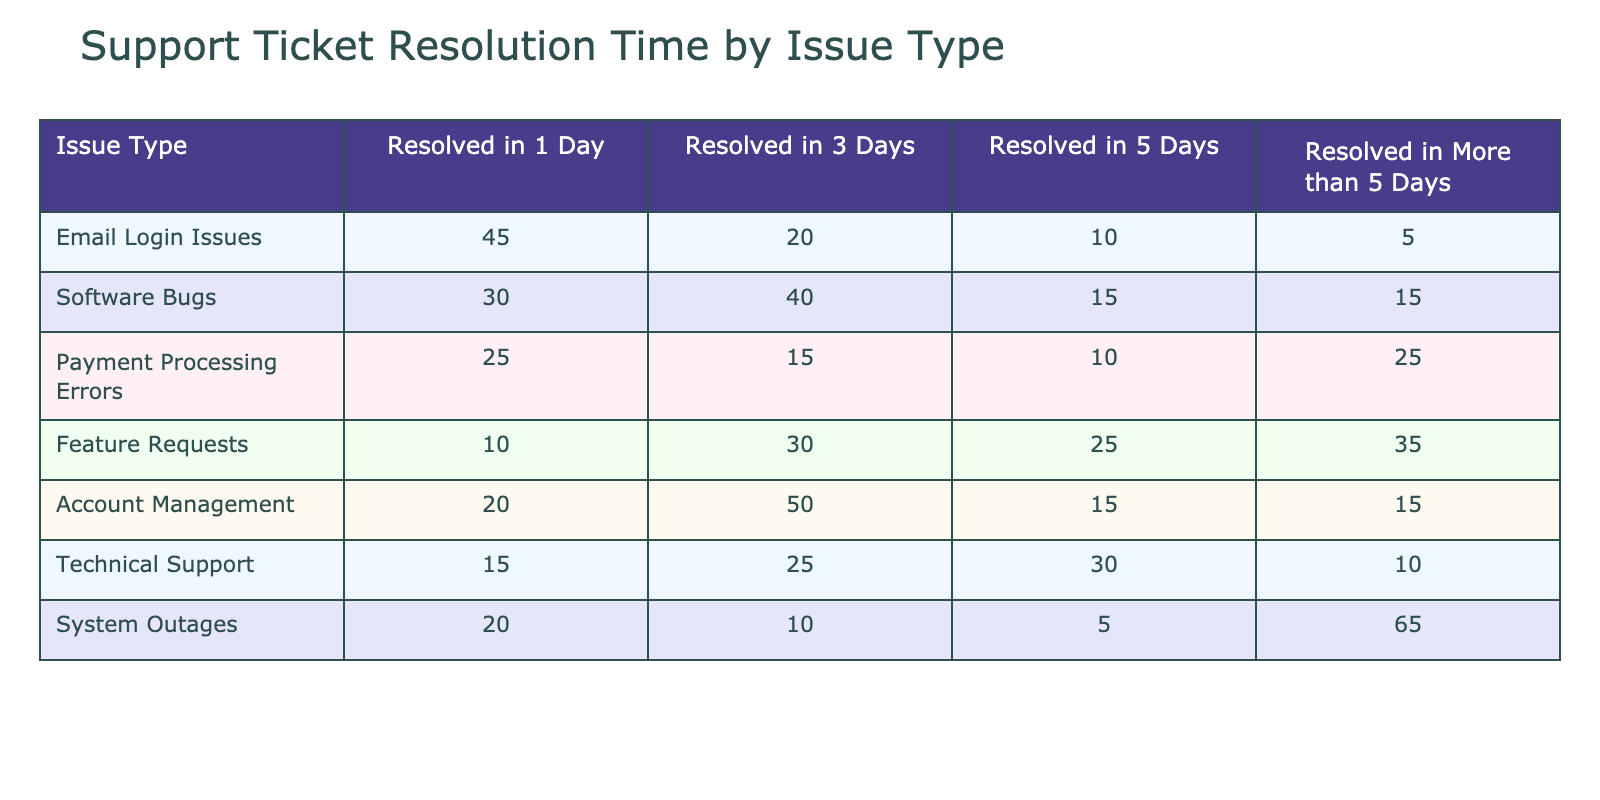What is the total number of tickets resolved in one day across all issue types? To find the total number of tickets resolved in one day, we sum the values of the "Resolved in 1 Day" column: 45 (Email Login Issues) + 30 (Software Bugs) + 25 (Payment Processing Errors) + 10 (Feature Requests) + 20 (Account Management) + 15 (Technical Support) + 20 (System Outages) = 165
Answer: 165 Which issue type took the longest to resolve on average? To determine which issue type took the longest, we need to find the row with the highest total in the "Resolved in More than 5 Days" column, as tickets going unresolved for more than 5 days indicates prolonged resolution. The highest value in this column is 65 (System Outages).
Answer: System Outages Are more tickets resolved in one day or three days across all issue types combined? We compare the totals for "Resolved in 1 Day" and "Resolved in 3 Days". The total for "Resolved in 1 Day" is 165, and for "Resolved in 3 Days" is 150. Since 165 > 150, more tickets are resolved in one day.
Answer: More tickets are resolved in one day What is the average resolution time for Feature Requests? For Feature Requests, the resolution times are weighted by the number of tickets resolved in each category: [(1*10) + (3*30) + (5*25) + (6*35)] / (10 + 30 + 25 + 35) = (10 + 90 + 125 + 210) / 100 = 425 / 100 = 4.25 days
Answer: 4.25 days Do more tickets related to Software Bugs or System Outages take longer than 5 days to resolve? We check the "Resolved in More than 5 Days" column: Software Bugs have 15 tickets, while System Outages have 65 tickets. Since 65 > 15, more System Outages take longer than 5 days.
Answer: Yes, more System Outages take longer than 5 days 